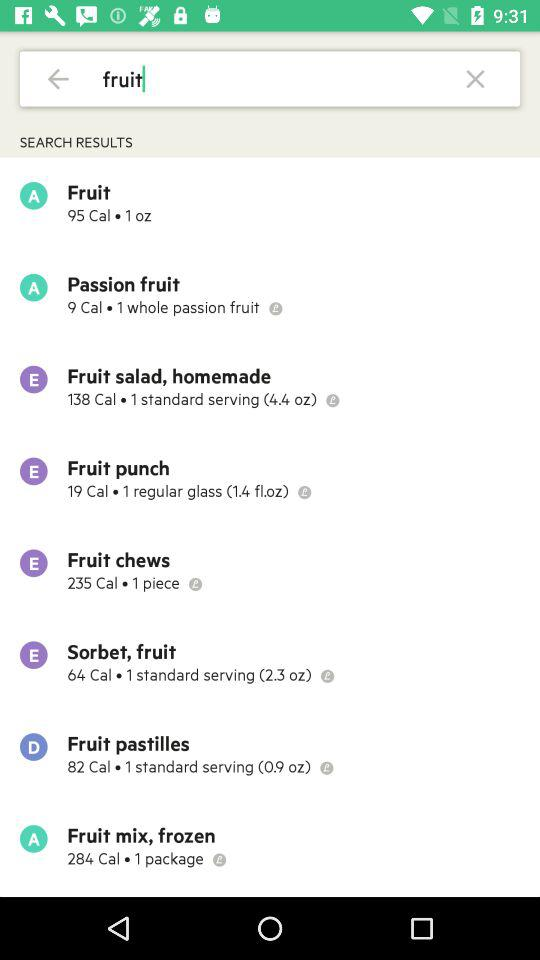How many calories are in a whole passion fruit?
Answer the question using a single word or phrase. 9 Cal 